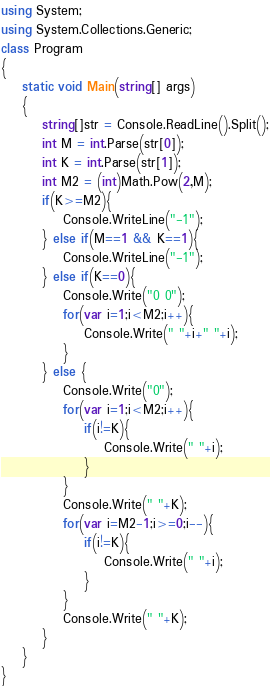<code> <loc_0><loc_0><loc_500><loc_500><_C#_>using System;
using System.Collections.Generic;
class Program
{
	static void Main(string[] args)
	{
		string[]str = Console.ReadLine().Split();
		int M = int.Parse(str[0]);
		int K = int.Parse(str[1]);
		int M2 = (int)Math.Pow(2,M);
		if(K>=M2){
			Console.WriteLine("-1");
		} else if(M==1 && K==1){
			Console.WriteLine("-1");
		} else if(K==0){
			Console.Write("0 0");
			for(var i=1;i<M2;i++){
				Console.Write(" "+i+" "+i);
			}
		} else {
			Console.Write("0");
			for(var i=1;i<M2;i++){
				if(i!=K){
					Console.Write(" "+i);
				}
			}
			Console.Write(" "+K);
			for(var i=M2-1;i>=0;i--){
				if(i!=K){
					Console.Write(" "+i);
				}
			}
			Console.Write(" "+K);
		}
	}
}</code> 